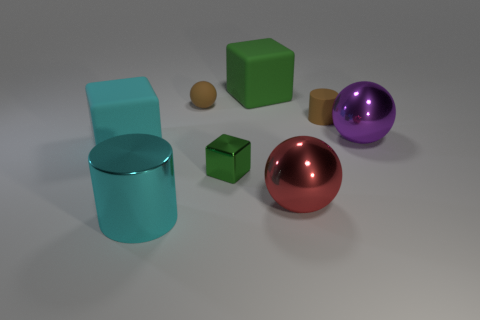The block that is the same color as the metal cylinder is what size?
Your response must be concise. Large. Are there fewer cyan cylinders that are to the left of the big red metallic sphere than rubber cylinders that are to the left of the brown matte ball?
Make the answer very short. No. How many cyan cubes have the same material as the tiny green thing?
Ensure brevity in your answer.  0. There is a large sphere right of the tiny brown thing to the right of the green rubber object; are there any purple spheres that are right of it?
Your answer should be compact. No. What number of cylinders are big cyan things or brown matte things?
Provide a short and direct response. 2. There is a tiny green object; is its shape the same as the large object to the right of the red sphere?
Your answer should be compact. No. Is the number of tiny objects in front of the small green metallic thing less than the number of cyan shiny objects?
Ensure brevity in your answer.  Yes. Are there any large things in front of the purple metallic sphere?
Keep it short and to the point. Yes. Are there any other green rubber objects of the same shape as the tiny green object?
Your response must be concise. Yes. There is a cyan matte thing that is the same size as the red sphere; what shape is it?
Your answer should be very brief. Cube. 